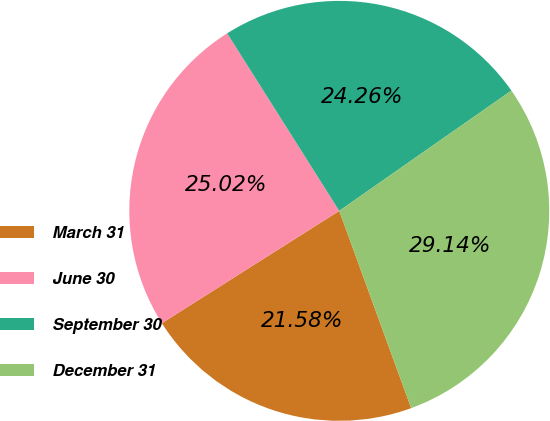Convert chart. <chart><loc_0><loc_0><loc_500><loc_500><pie_chart><fcel>March 31<fcel>June 30<fcel>September 30<fcel>December 31<nl><fcel>21.58%<fcel>25.02%<fcel>24.26%<fcel>29.14%<nl></chart> 